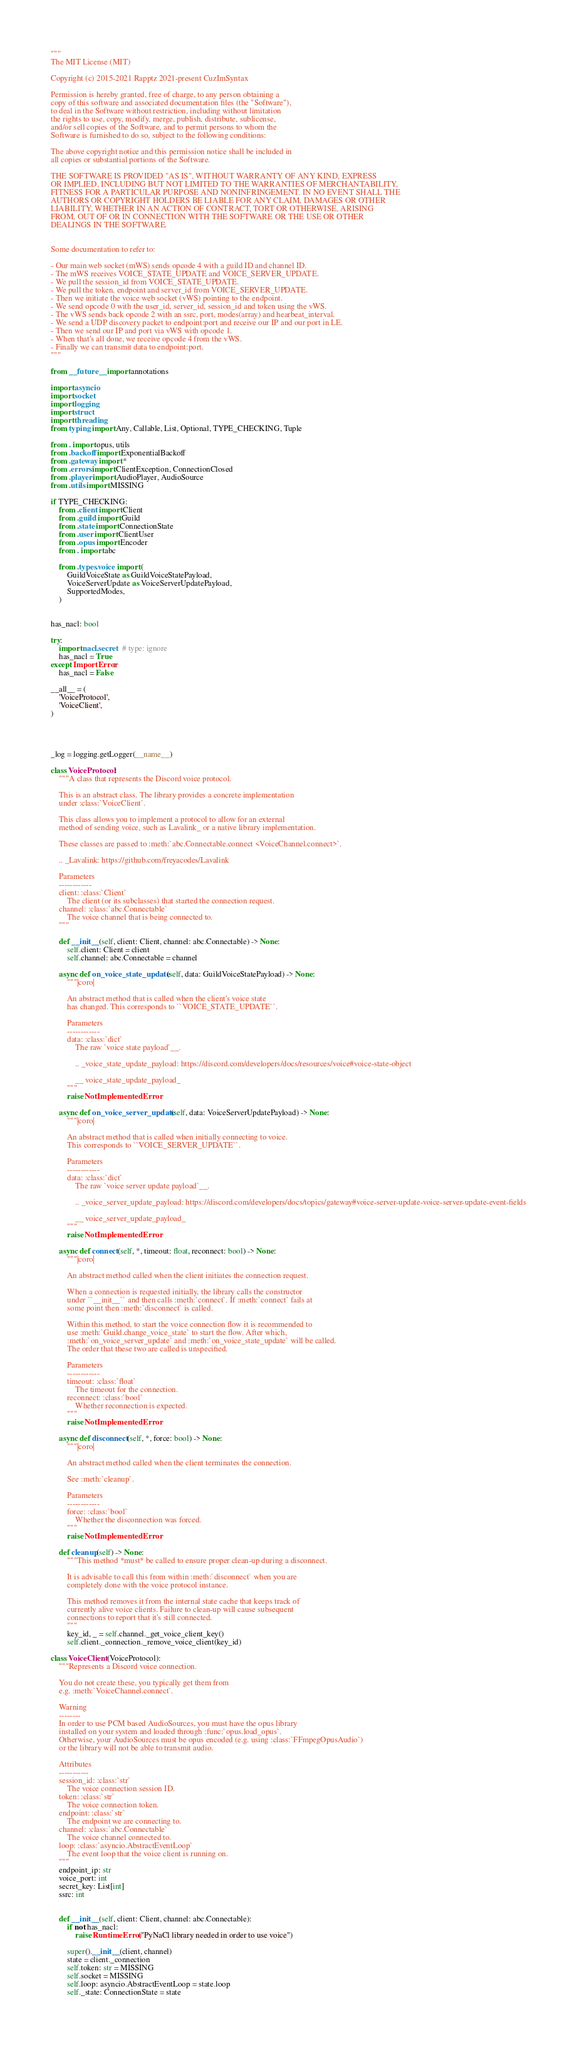Convert code to text. <code><loc_0><loc_0><loc_500><loc_500><_Python_>"""
The MIT License (MIT)

Copyright (c) 2015-2021 Rapptz 2021-present CuzImSyntax

Permission is hereby granted, free of charge, to any person obtaining a
copy of this software and associated documentation files (the "Software"),
to deal in the Software without restriction, including without limitation
the rights to use, copy, modify, merge, publish, distribute, sublicense,
and/or sell copies of the Software, and to permit persons to whom the
Software is furnished to do so, subject to the following conditions:

The above copyright notice and this permission notice shall be included in
all copies or substantial portions of the Software.

THE SOFTWARE IS PROVIDED "AS IS", WITHOUT WARRANTY OF ANY KIND, EXPRESS
OR IMPLIED, INCLUDING BUT NOT LIMITED TO THE WARRANTIES OF MERCHANTABILITY,
FITNESS FOR A PARTICULAR PURPOSE AND NONINFRINGEMENT. IN NO EVENT SHALL THE
AUTHORS OR COPYRIGHT HOLDERS BE LIABLE FOR ANY CLAIM, DAMAGES OR OTHER
LIABILITY, WHETHER IN AN ACTION OF CONTRACT, TORT OR OTHERWISE, ARISING
FROM, OUT OF OR IN CONNECTION WITH THE SOFTWARE OR THE USE OR OTHER
DEALINGS IN THE SOFTWARE.


Some documentation to refer to:

- Our main web socket (mWS) sends opcode 4 with a guild ID and channel ID.
- The mWS receives VOICE_STATE_UPDATE and VOICE_SERVER_UPDATE.
- We pull the session_id from VOICE_STATE_UPDATE.
- We pull the token, endpoint and server_id from VOICE_SERVER_UPDATE.
- Then we initiate the voice web socket (vWS) pointing to the endpoint.
- We send opcode 0 with the user_id, server_id, session_id and token using the vWS.
- The vWS sends back opcode 2 with an ssrc, port, modes(array) and hearbeat_interval.
- We send a UDP discovery packet to endpoint:port and receive our IP and our port in LE.
- Then we send our IP and port via vWS with opcode 1.
- When that's all done, we receive opcode 4 from the vWS.
- Finally we can transmit data to endpoint:port.
"""

from __future__ import annotations

import asyncio
import socket
import logging
import struct
import threading
from typing import Any, Callable, List, Optional, TYPE_CHECKING, Tuple

from . import opus, utils
from .backoff import ExponentialBackoff
from .gateway import *
from .errors import ClientException, ConnectionClosed
from .player import AudioPlayer, AudioSource
from .utils import MISSING

if TYPE_CHECKING:
    from .client import Client
    from .guild import Guild
    from .state import ConnectionState
    from .user import ClientUser
    from .opus import Encoder
    from . import abc

    from .types.voice import (
        GuildVoiceState as GuildVoiceStatePayload,
        VoiceServerUpdate as VoiceServerUpdatePayload,
        SupportedModes,
    )
    

has_nacl: bool

try:
    import nacl.secret  # type: ignore
    has_nacl = True
except ImportError:
    has_nacl = False

__all__ = (
    'VoiceProtocol',
    'VoiceClient',
)




_log = logging.getLogger(__name__)

class VoiceProtocol:
    """A class that represents the Discord voice protocol.

    This is an abstract class. The library provides a concrete implementation
    under :class:`VoiceClient`.

    This class allows you to implement a protocol to allow for an external
    method of sending voice, such as Lavalink_ or a native library implementation.

    These classes are passed to :meth:`abc.Connectable.connect <VoiceChannel.connect>`.

    .. _Lavalink: https://github.com/freyacodes/Lavalink

    Parameters
    ------------
    client: :class:`Client`
        The client (or its subclasses) that started the connection request.
    channel: :class:`abc.Connectable`
        The voice channel that is being connected to.
    """

    def __init__(self, client: Client, channel: abc.Connectable) -> None:
        self.client: Client = client
        self.channel: abc.Connectable = channel

    async def on_voice_state_update(self, data: GuildVoiceStatePayload) -> None:
        """|coro|

        An abstract method that is called when the client's voice state
        has changed. This corresponds to ``VOICE_STATE_UPDATE``.

        Parameters
        ------------
        data: :class:`dict`
            The raw `voice state payload`__.

            .. _voice_state_update_payload: https://discord.com/developers/docs/resources/voice#voice-state-object

            __ voice_state_update_payload_
        """
        raise NotImplementedError

    async def on_voice_server_update(self, data: VoiceServerUpdatePayload) -> None:
        """|coro|

        An abstract method that is called when initially connecting to voice.
        This corresponds to ``VOICE_SERVER_UPDATE``.

        Parameters
        ------------
        data: :class:`dict`
            The raw `voice server update payload`__.

            .. _voice_server_update_payload: https://discord.com/developers/docs/topics/gateway#voice-server-update-voice-server-update-event-fields

            __ voice_server_update_payload_
        """
        raise NotImplementedError

    async def connect(self, *, timeout: float, reconnect: bool) -> None:
        """|coro|

        An abstract method called when the client initiates the connection request.

        When a connection is requested initially, the library calls the constructor
        under ``__init__`` and then calls :meth:`connect`. If :meth:`connect` fails at
        some point then :meth:`disconnect` is called.

        Within this method, to start the voice connection flow it is recommended to
        use :meth:`Guild.change_voice_state` to start the flow. After which,
        :meth:`on_voice_server_update` and :meth:`on_voice_state_update` will be called.
        The order that these two are called is unspecified.

        Parameters
        ------------
        timeout: :class:`float`
            The timeout for the connection.
        reconnect: :class:`bool`
            Whether reconnection is expected.
        """
        raise NotImplementedError

    async def disconnect(self, *, force: bool) -> None:
        """|coro|

        An abstract method called when the client terminates the connection.

        See :meth:`cleanup`.

        Parameters
        ------------
        force: :class:`bool`
            Whether the disconnection was forced.
        """
        raise NotImplementedError

    def cleanup(self) -> None:
        """This method *must* be called to ensure proper clean-up during a disconnect.

        It is advisable to call this from within :meth:`disconnect` when you are
        completely done with the voice protocol instance.

        This method removes it from the internal state cache that keeps track of
        currently alive voice clients. Failure to clean-up will cause subsequent
        connections to report that it's still connected.
        """
        key_id, _ = self.channel._get_voice_client_key()
        self.client._connection._remove_voice_client(key_id)

class VoiceClient(VoiceProtocol):
    """Represents a Discord voice connection.

    You do not create these, you typically get them from
    e.g. :meth:`VoiceChannel.connect`.

    Warning
    --------
    In order to use PCM based AudioSources, you must have the opus library
    installed on your system and loaded through :func:`opus.load_opus`.
    Otherwise, your AudioSources must be opus encoded (e.g. using :class:`FFmpegOpusAudio`)
    or the library will not be able to transmit audio.

    Attributes
    -----------
    session_id: :class:`str`
        The voice connection session ID.
    token: :class:`str`
        The voice connection token.
    endpoint: :class:`str`
        The endpoint we are connecting to.
    channel: :class:`abc.Connectable`
        The voice channel connected to.
    loop: :class:`asyncio.AbstractEventLoop`
        The event loop that the voice client is running on.
    """
    endpoint_ip: str
    voice_port: int
    secret_key: List[int]
    ssrc: int


    def __init__(self, client: Client, channel: abc.Connectable):
        if not has_nacl:
            raise RuntimeError("PyNaCl library needed in order to use voice")

        super().__init__(client, channel)
        state = client._connection
        self.token: str = MISSING
        self.socket = MISSING
        self.loop: asyncio.AbstractEventLoop = state.loop
        self._state: ConnectionState = state</code> 